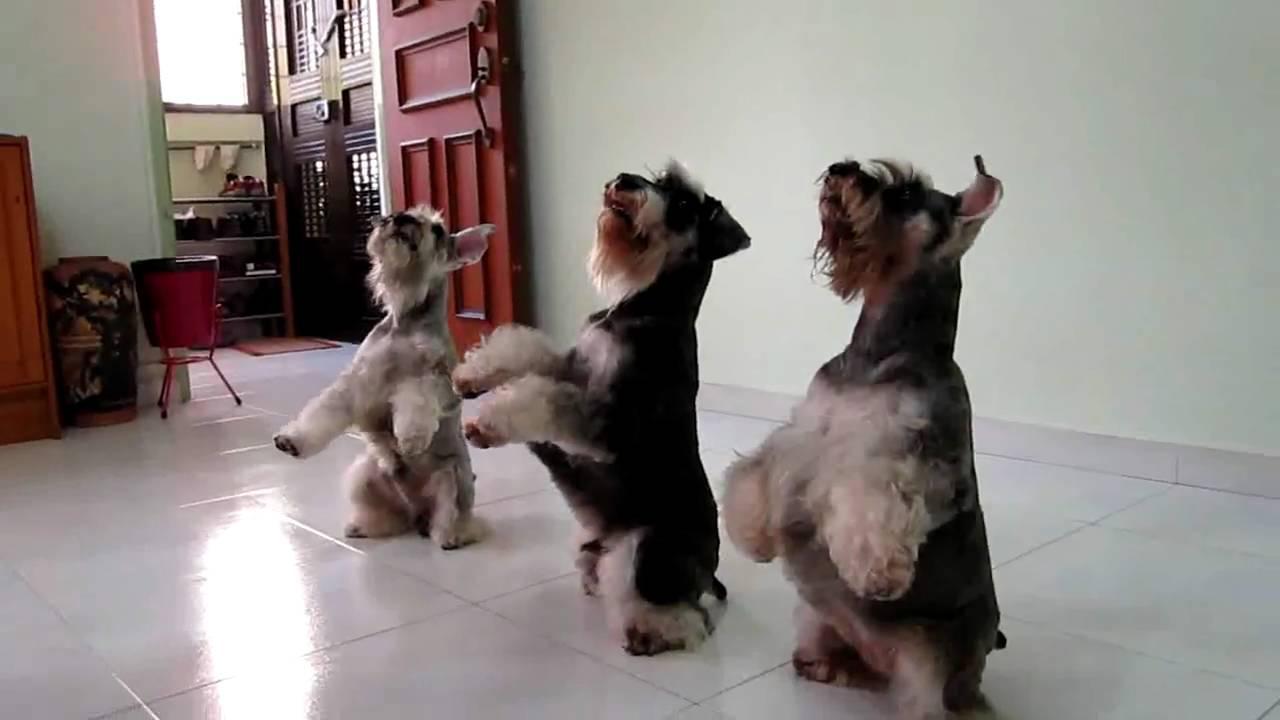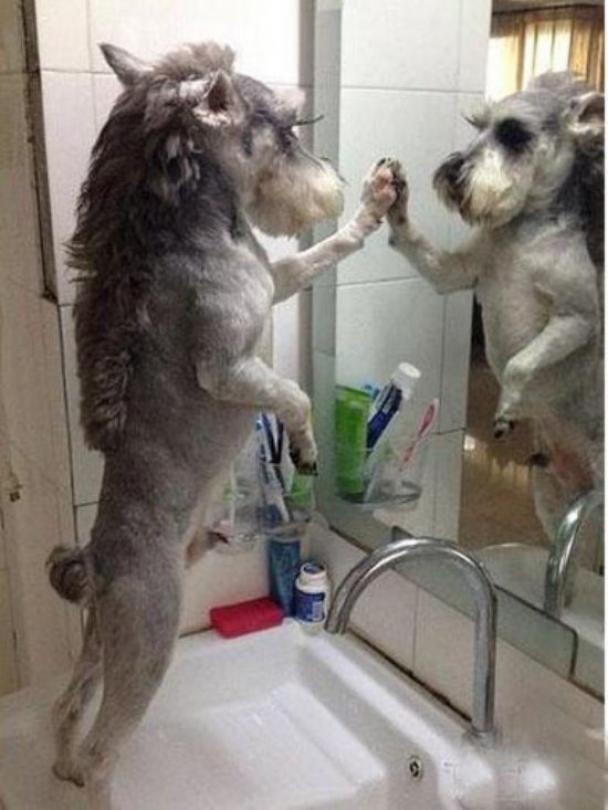The first image is the image on the left, the second image is the image on the right. For the images displayed, is the sentence "At least one schnauzer is in front of a white wall in a balancing upright pose, with its front paws not supported by anything." factually correct? Answer yes or no. Yes. The first image is the image on the left, the second image is the image on the right. Assess this claim about the two images: "The dog in the image on the right is standing on two legs.". Correct or not? Answer yes or no. Yes. 